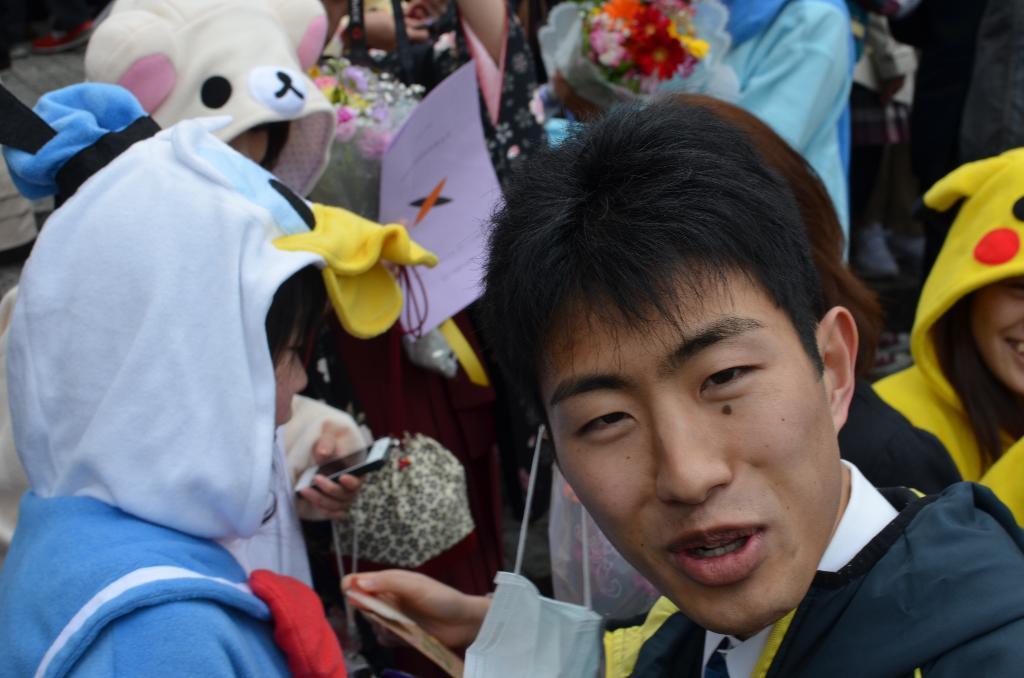Could you give a brief overview of what you see in this image? In this image we can see people, flowers and paper. One person is holding a mobile. 